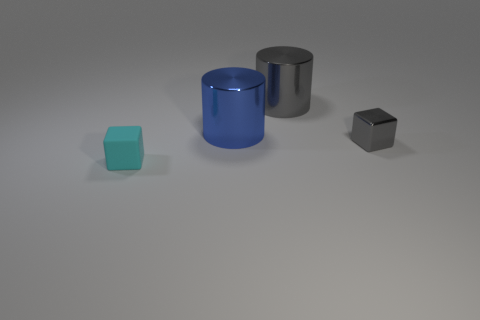How many objects are gray metal cylinders or blue objects?
Your answer should be very brief. 2. Is there anything else that has the same material as the gray cube?
Your answer should be compact. Yes. There is a big gray shiny object; what shape is it?
Offer a very short reply. Cylinder. There is a tiny object behind the tiny object that is to the left of the tiny shiny object; what shape is it?
Offer a terse response. Cube. Does the small thing behind the tiny cyan object have the same material as the small cyan thing?
Your answer should be compact. No. What number of cyan objects are tiny metallic things or large balls?
Provide a short and direct response. 0. Is there a tiny matte thing of the same color as the small shiny block?
Keep it short and to the point. No. Is there another gray cylinder that has the same material as the large gray cylinder?
Your response must be concise. No. The thing that is both to the right of the big blue object and in front of the blue shiny thing has what shape?
Ensure brevity in your answer.  Cube. How many large objects are blue metal objects or gray metal things?
Give a very brief answer. 2. 